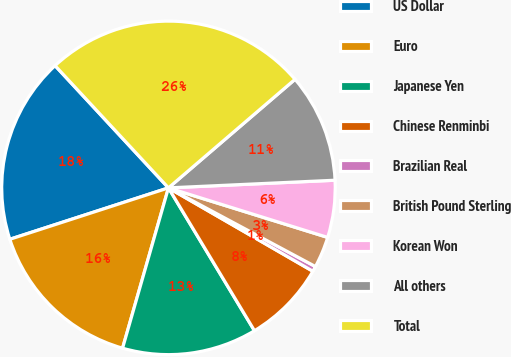<chart> <loc_0><loc_0><loc_500><loc_500><pie_chart><fcel>US Dollar<fcel>Euro<fcel>Japanese Yen<fcel>Chinese Renminbi<fcel>Brazilian Real<fcel>British Pound Sterling<fcel>Korean Won<fcel>All others<fcel>Total<nl><fcel>18.08%<fcel>15.57%<fcel>13.06%<fcel>8.04%<fcel>0.51%<fcel>3.02%<fcel>5.53%<fcel>10.55%<fcel>25.61%<nl></chart> 